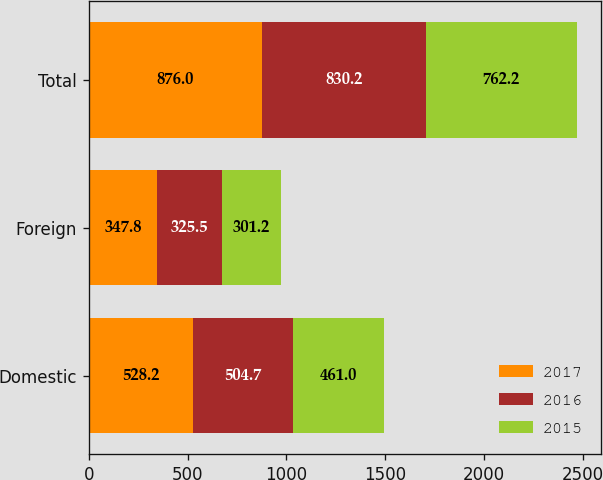<chart> <loc_0><loc_0><loc_500><loc_500><stacked_bar_chart><ecel><fcel>Domestic<fcel>Foreign<fcel>Total<nl><fcel>2017<fcel>528.2<fcel>347.8<fcel>876<nl><fcel>2016<fcel>504.7<fcel>325.5<fcel>830.2<nl><fcel>2015<fcel>461<fcel>301.2<fcel>762.2<nl></chart> 